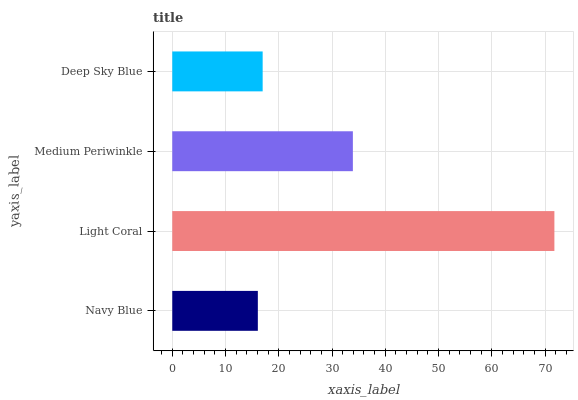Is Navy Blue the minimum?
Answer yes or no. Yes. Is Light Coral the maximum?
Answer yes or no. Yes. Is Medium Periwinkle the minimum?
Answer yes or no. No. Is Medium Periwinkle the maximum?
Answer yes or no. No. Is Light Coral greater than Medium Periwinkle?
Answer yes or no. Yes. Is Medium Periwinkle less than Light Coral?
Answer yes or no. Yes. Is Medium Periwinkle greater than Light Coral?
Answer yes or no. No. Is Light Coral less than Medium Periwinkle?
Answer yes or no. No. Is Medium Periwinkle the high median?
Answer yes or no. Yes. Is Deep Sky Blue the low median?
Answer yes or no. Yes. Is Light Coral the high median?
Answer yes or no. No. Is Navy Blue the low median?
Answer yes or no. No. 